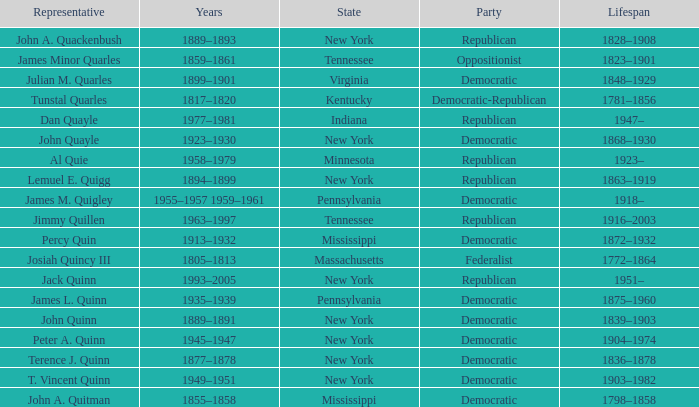Which state does Jimmy Quillen represent? Tennessee. 